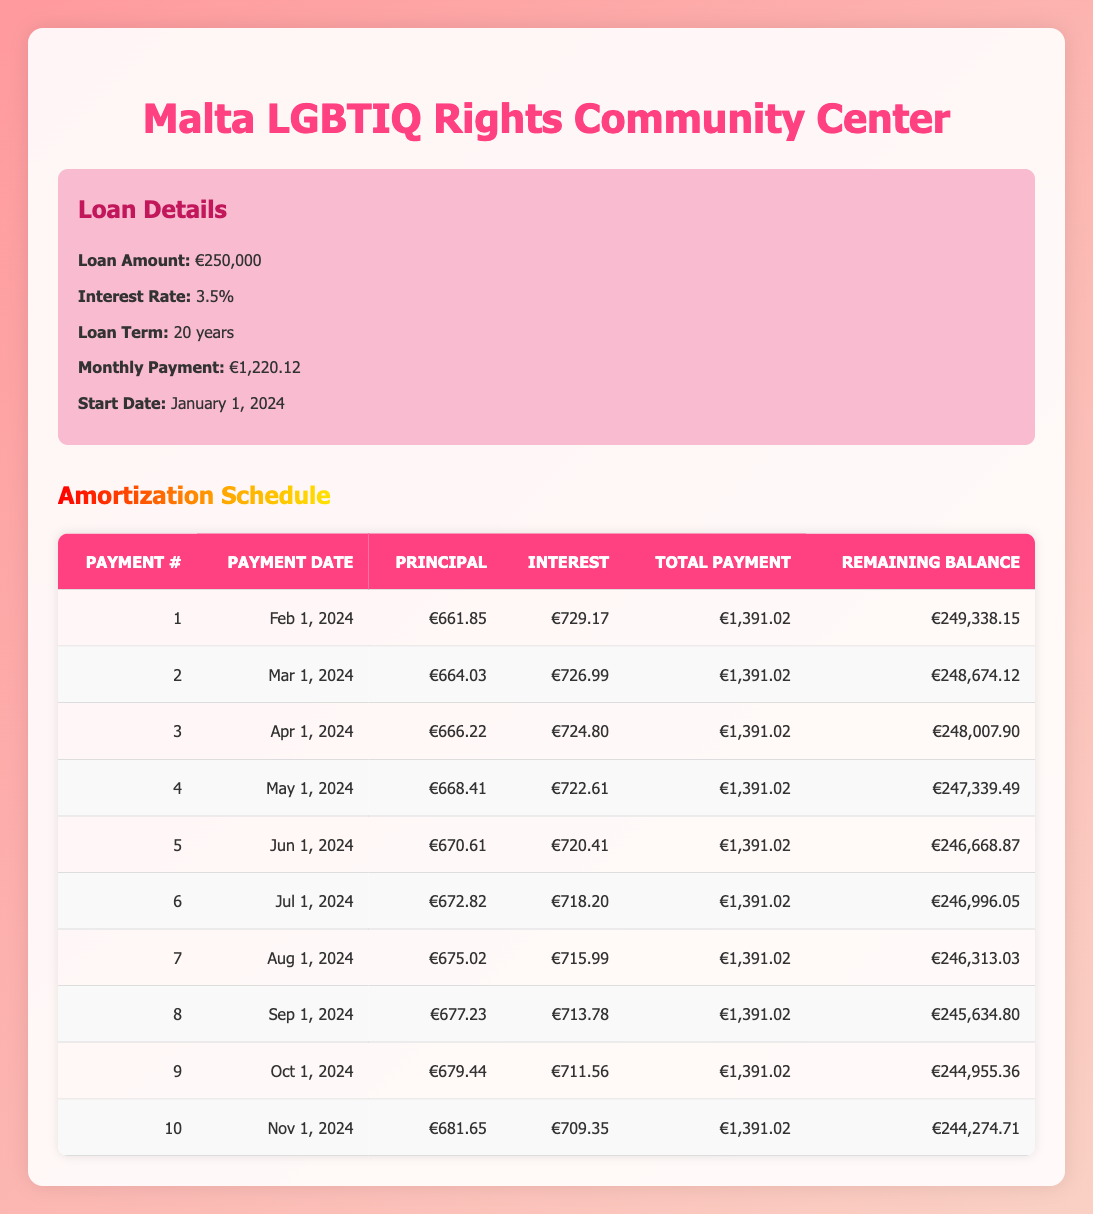What is the principal payment for the first month? The first row of the table indicates the principal payment for the first payment is €661.85.
Answer: €661.85 What is the total payment due in the second month? The second row shows that the total payment due in the second month is €1,391.02.
Answer: €1,391.02 What is the remaining balance after the third payment? The remaining balance after the third payment, as shown in the third row, is €248,007.90.
Answer: €248,007.90 How much interest is paid in the fifth month? The fifth row shows that the interest payment in the fifth month is €720.41.
Answer: €720.41 Is the total payment same for all months listed? Yes, based on the rows of the table, the total payment remains consistent at €1,391.02 each month.
Answer: Yes What is the total principal paid after the first six payments? To find this, sum the principal payments of the first six rows: €661.85 + €664.03 + €666.22 + €668.41 + €670.61 + €672.82 = €4,103.14.
Answer: €4,103.14 If the trend continues, will the remaining balance drop below €245,000 after the eighth payment? By examining the remaining balances, after the eighth payment, the remaining balance is projected to be €245,634.80, which is still above €245,000. Therefore, the answer is no.
Answer: No What is the change in the remaining balance from the second to the tenth payment? The remaining balance after the second payment is €248,674.12 and after the tenth payment, it is €244,274.71. The change is €248,674.12 - €244,274.71 = €4,399.41.
Answer: €4,399.41 How much more is paid in interest compared to principal in the first payment? The interest payment in the first payment is €729.17 and the principal payment is €661.85. Therefore, the difference is €729.17 - €661.85 = €67.32.
Answer: €67.32 